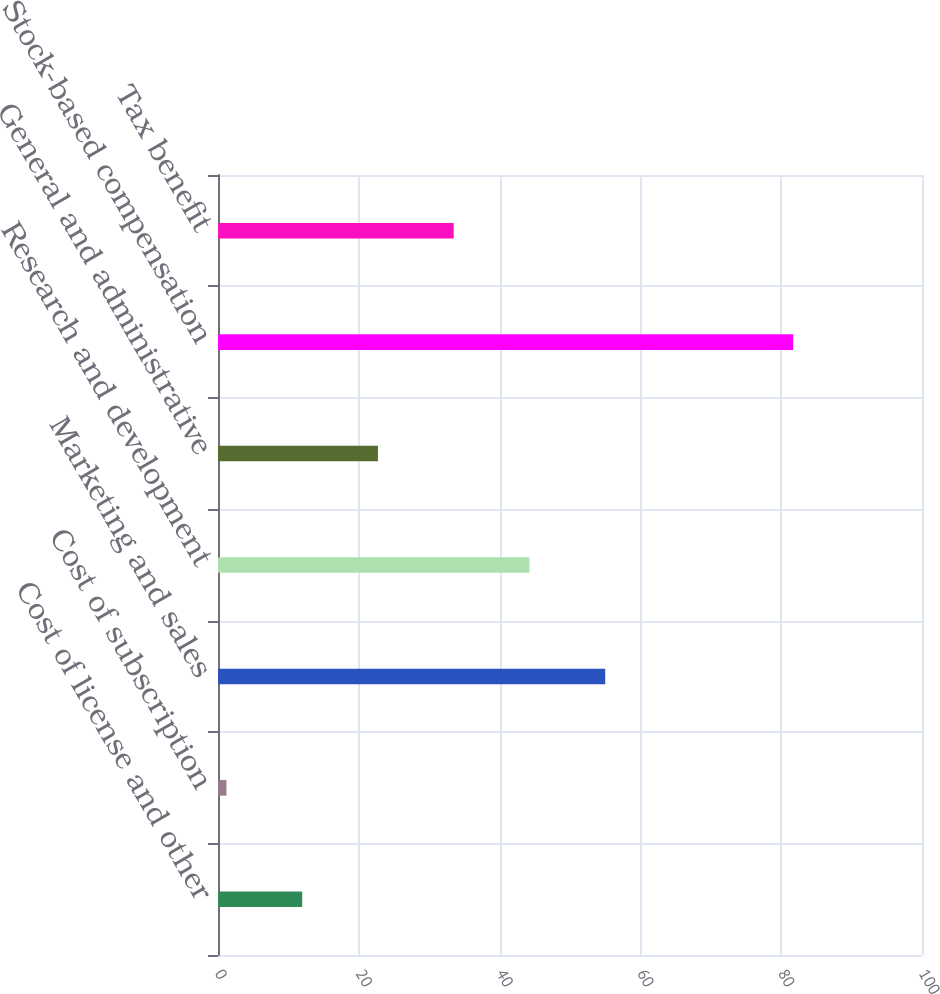Convert chart. <chart><loc_0><loc_0><loc_500><loc_500><bar_chart><fcel>Cost of license and other<fcel>Cost of subscription<fcel>Marketing and sales<fcel>Research and development<fcel>General and administrative<fcel>Stock-based compensation<fcel>Tax benefit<nl><fcel>11.96<fcel>1.2<fcel>55<fcel>44.24<fcel>22.72<fcel>81.7<fcel>33.48<nl></chart> 